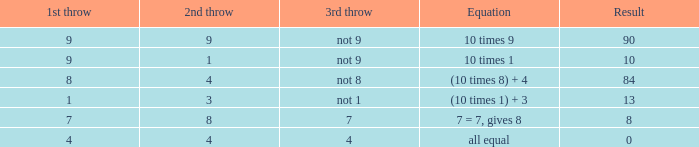When the equation is balanced, what is the value of the third throw? 4.0. 